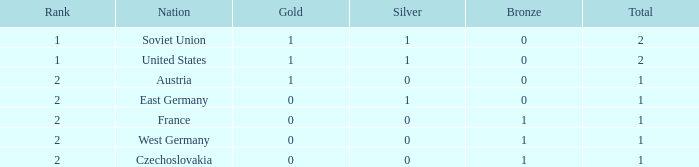What is the highest rank of Austria, which had less than 0 silvers? None. 